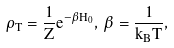<formula> <loc_0><loc_0><loc_500><loc_500>\rho _ { T } = \frac { 1 } { Z } e ^ { - \beta H _ { 0 } } , \, \beta = \frac { 1 } { k _ { B } T } ,</formula> 